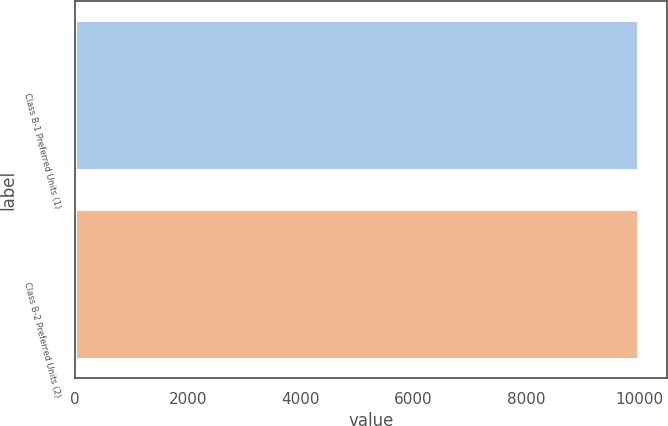Convert chart to OTSL. <chart><loc_0><loc_0><loc_500><loc_500><bar_chart><fcel>Class B-1 Preferred Units (1)<fcel>Class B-2 Preferred Units (2)<nl><fcel>10000<fcel>10000.1<nl></chart> 